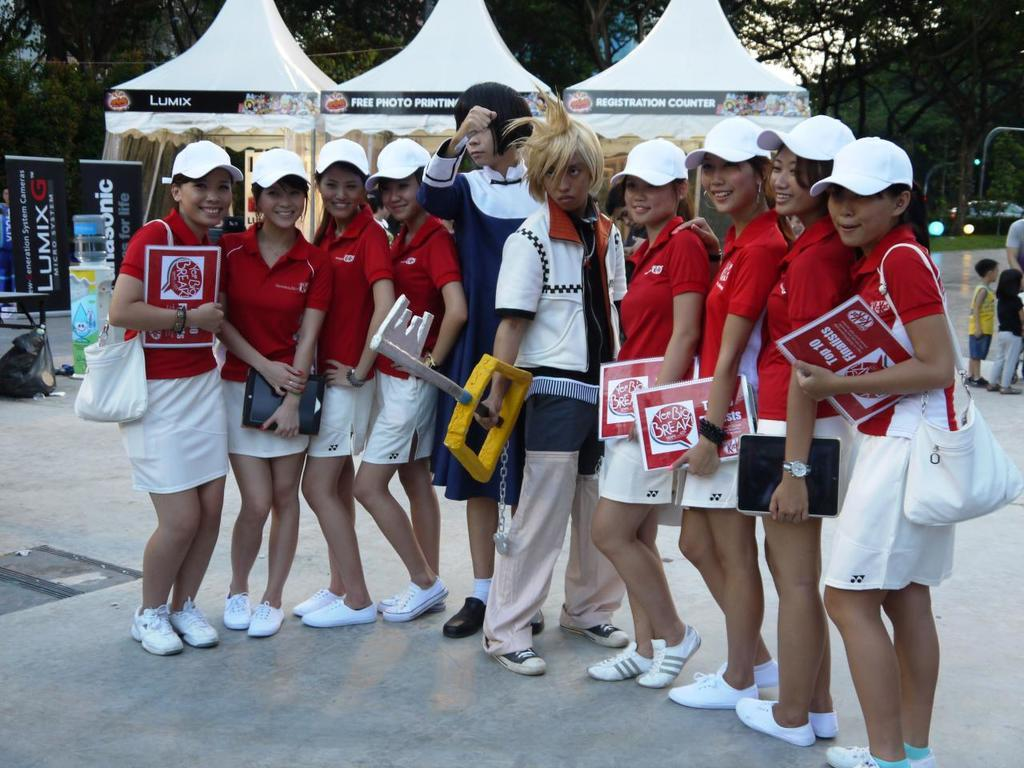<image>
Provide a brief description of the given image. A group of girls hold red and white papers with the words your big break on them. 